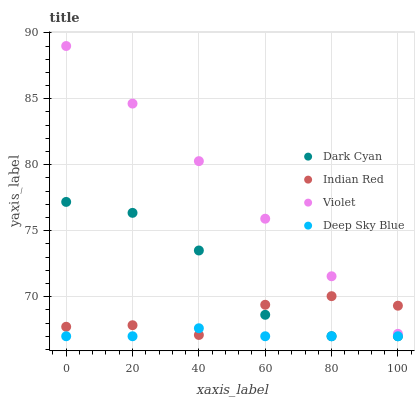Does Deep Sky Blue have the minimum area under the curve?
Answer yes or no. Yes. Does Violet have the maximum area under the curve?
Answer yes or no. Yes. Does Indian Red have the minimum area under the curve?
Answer yes or no. No. Does Indian Red have the maximum area under the curve?
Answer yes or no. No. Is Violet the smoothest?
Answer yes or no. Yes. Is Dark Cyan the roughest?
Answer yes or no. Yes. Is Deep Sky Blue the smoothest?
Answer yes or no. No. Is Deep Sky Blue the roughest?
Answer yes or no. No. Does Dark Cyan have the lowest value?
Answer yes or no. Yes. Does Indian Red have the lowest value?
Answer yes or no. No. Does Violet have the highest value?
Answer yes or no. Yes. Does Indian Red have the highest value?
Answer yes or no. No. Is Dark Cyan less than Violet?
Answer yes or no. Yes. Is Violet greater than Dark Cyan?
Answer yes or no. Yes. Does Deep Sky Blue intersect Dark Cyan?
Answer yes or no. Yes. Is Deep Sky Blue less than Dark Cyan?
Answer yes or no. No. Is Deep Sky Blue greater than Dark Cyan?
Answer yes or no. No. Does Dark Cyan intersect Violet?
Answer yes or no. No. 